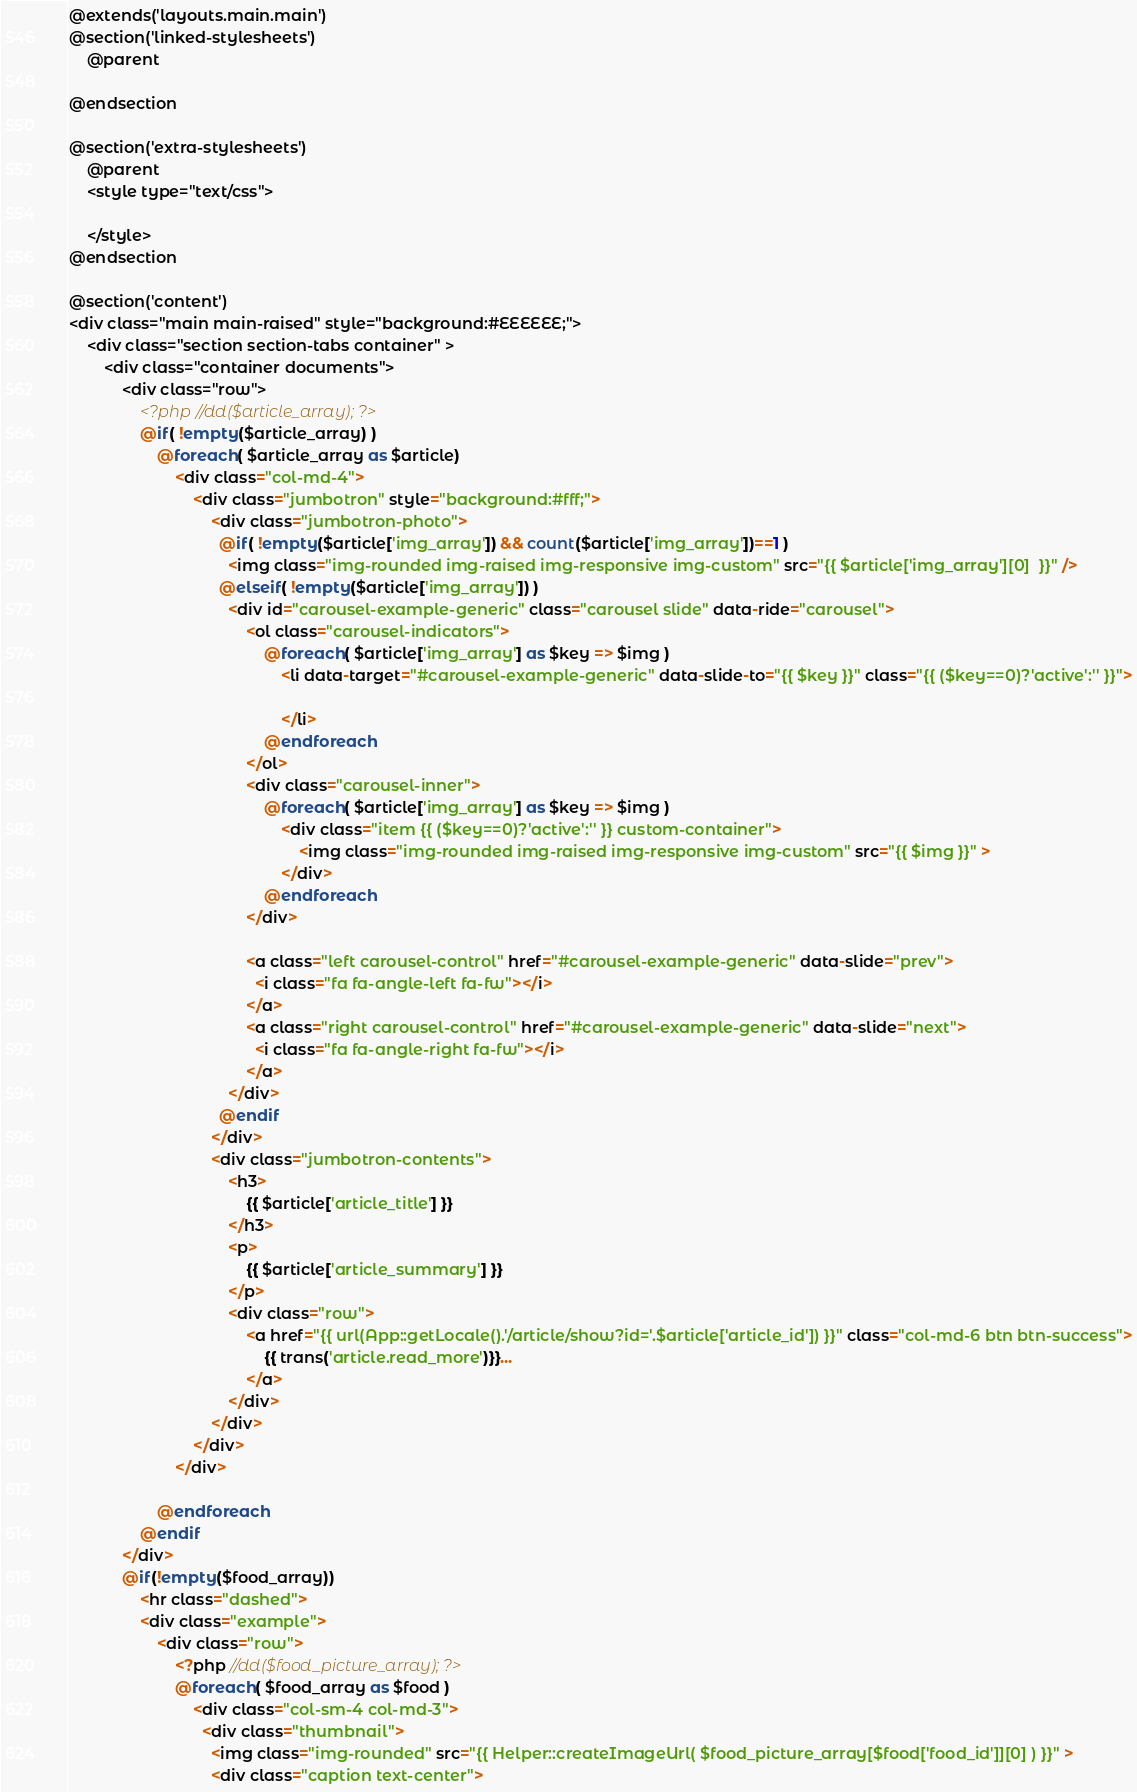Convert code to text. <code><loc_0><loc_0><loc_500><loc_500><_PHP_>@extends('layouts.main.main')
@section('linked-stylesheets')
    @parent
    
@endsection

@section('extra-stylesheets')
    @parent
    <style type="text/css">

    </style>
@endsection

@section('content')
<div class="main main-raised" style="background:#EEEEEE;">
    <div class="section section-tabs container" >
        <div class="container documents">
            <div class="row">
                <?php //dd($article_array); ?>
                @if( !empty($article_array) )  
                    @foreach( $article_array as $article)  
                        <div class="col-md-4">
                            <div class="jumbotron" style="background:#fff;">
                                <div class="jumbotron-photo">
                                  @if( !empty($article['img_array']) && count($article['img_array'])==1 )  
                                    <img class="img-rounded img-raised img-responsive img-custom" src="{{ $article['img_array'][0]  }}" />
                                  @elseif( !empty($article['img_array']) )
                                    <div id="carousel-example-generic" class="carousel slide" data-ride="carousel">
                                        <ol class="carousel-indicators">
                                            @foreach( $article['img_array'] as $key => $img )
                                                <li data-target="#carousel-example-generic" data-slide-to="{{ $key }}" class="{{ ($key==0)?'active':'' }}">

                                                </li>
                                            @endforeach
                                        </ol>
                                        <div class="carousel-inner">
                                            @foreach( $article['img_array'] as $key => $img )
                                                <div class="item {{ ($key==0)?'active':'' }} custom-container">
                                                    <img class="img-rounded img-raised img-responsive img-custom" src="{{ $img }}" >
                                                </div>
                                            @endforeach
                                        </div>

                                        <a class="left carousel-control" href="#carousel-example-generic" data-slide="prev">
                                          <i class="fa fa-angle-left fa-fw"></i>
                                        </a>
                                        <a class="right carousel-control" href="#carousel-example-generic" data-slide="next">
                                          <i class="fa fa-angle-right fa-fw"></i>
                                        </a>
                                    </div>
                                  @endif
                                </div>
                                <div class="jumbotron-contents">
                                    <h3>
                                        {{ $article['article_title'] }}
                                    </h3>
                                    <p>
                                        {{ $article['article_summary'] }}
                                    </p>
                                    <div class="row">
                                        <a href="{{ url(App::getLocale().'/article/show?id='.$article['article_id']) }}" class="col-md-6 btn btn-success">
                                            {{ trans('article.read_more')}}...
                                        </a>
                                    </div>        
                                </div>
                            </div>                
                        </div>

                    @endforeach 
                @endif  
            </div>
            @if(!empty($food_array))    
                <hr class="dashed">      
                <div class="example">
                    <div class="row">
                        <?php //dd($food_picture_array); ?>
                        @foreach( $food_array as $food )
                            <div class="col-sm-4 col-md-3">
                              <div class="thumbnail">
                                <img class="img-rounded" src="{{ Helper::createImageUrl( $food_picture_array[$food['food_id']][0] ) }}" >
                                <div class="caption text-center"></code> 